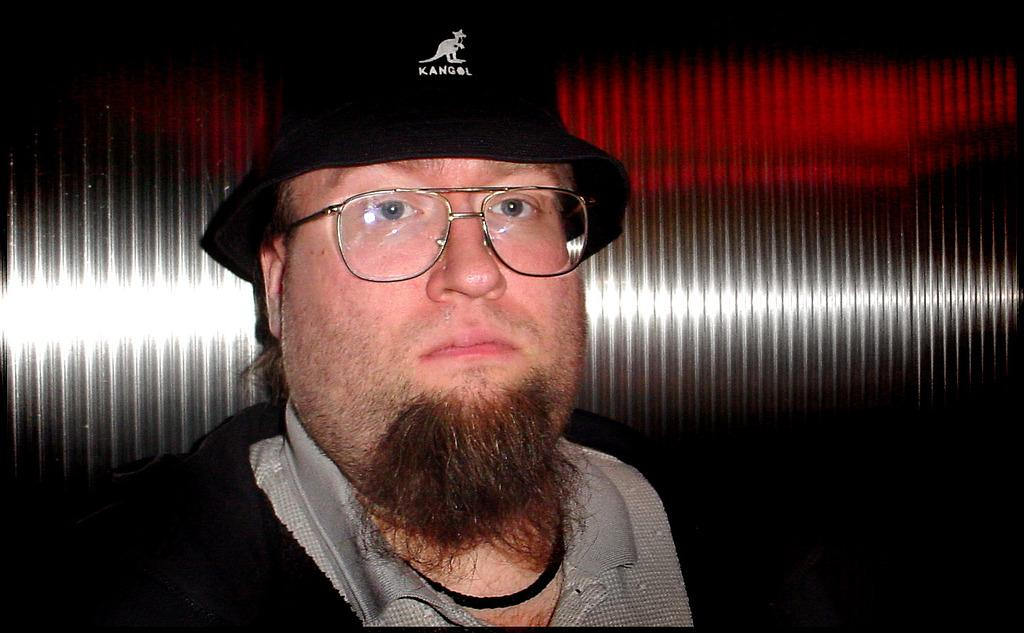Who is present in the image? There is a man in the image. What is the man wearing on his head? The man is wearing a cap. What is the man wearing on his face? The man is wearing spectacles. What is the man doing in the image? The man is watching something. What can be seen in the background of the image? There is a steel object in the background of the image. What type of creature is the man taking care of in the image? There is no creature present in the image; the man is simply watching something. What is the aftermath of the event in the image? There is no event depicted in the image, so it's not possible to determine the aftermath. 